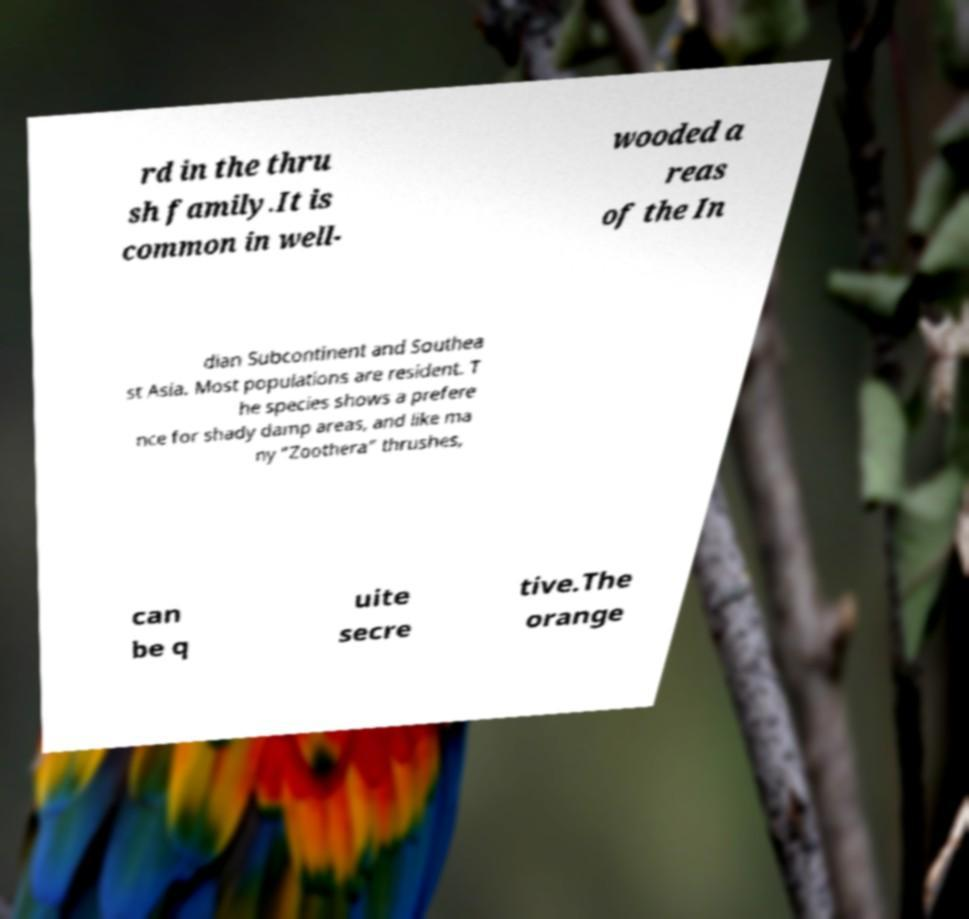For documentation purposes, I need the text within this image transcribed. Could you provide that? rd in the thru sh family.It is common in well- wooded a reas of the In dian Subcontinent and Southea st Asia. Most populations are resident. T he species shows a prefere nce for shady damp areas, and like ma ny "Zoothera" thrushes, can be q uite secre tive.The orange 